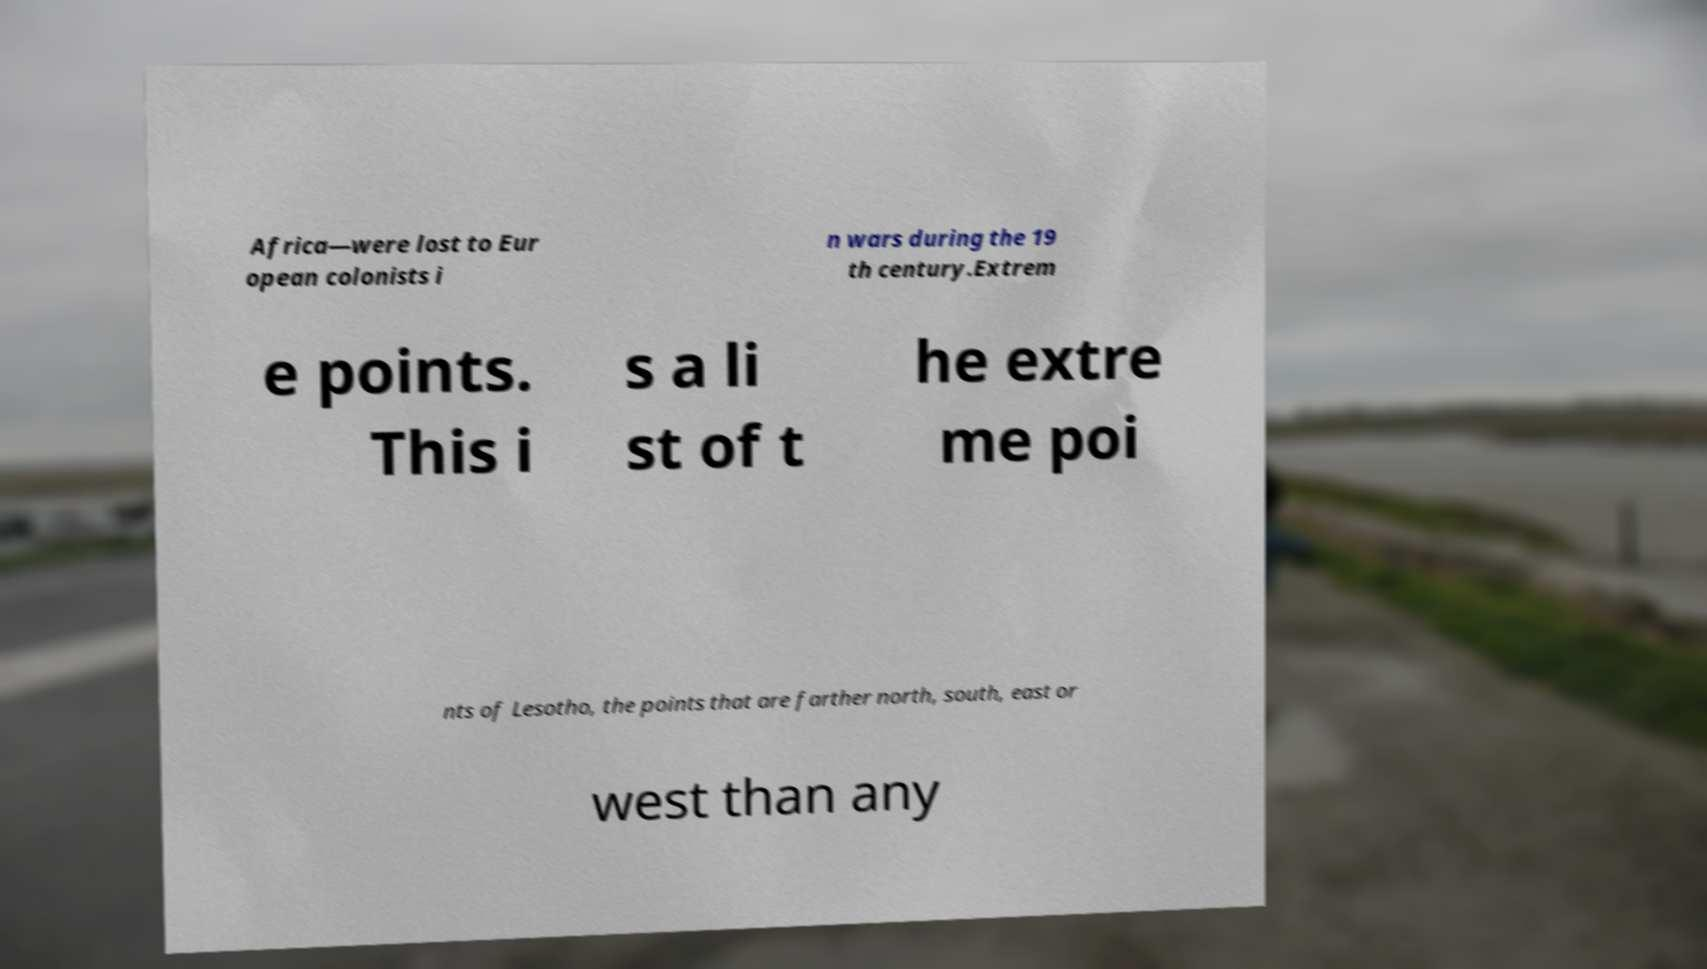What messages or text are displayed in this image? I need them in a readable, typed format. Africa—were lost to Eur opean colonists i n wars during the 19 th century.Extrem e points. This i s a li st of t he extre me poi nts of Lesotho, the points that are farther north, south, east or west than any 